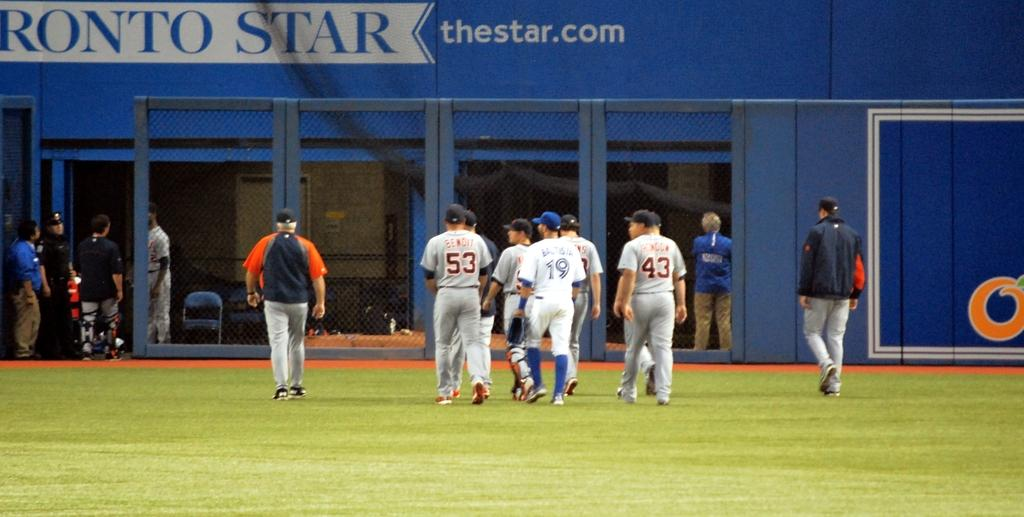<image>
Offer a succinct explanation of the picture presented. a baseball team walks off of a field that is advertising thestar.com 